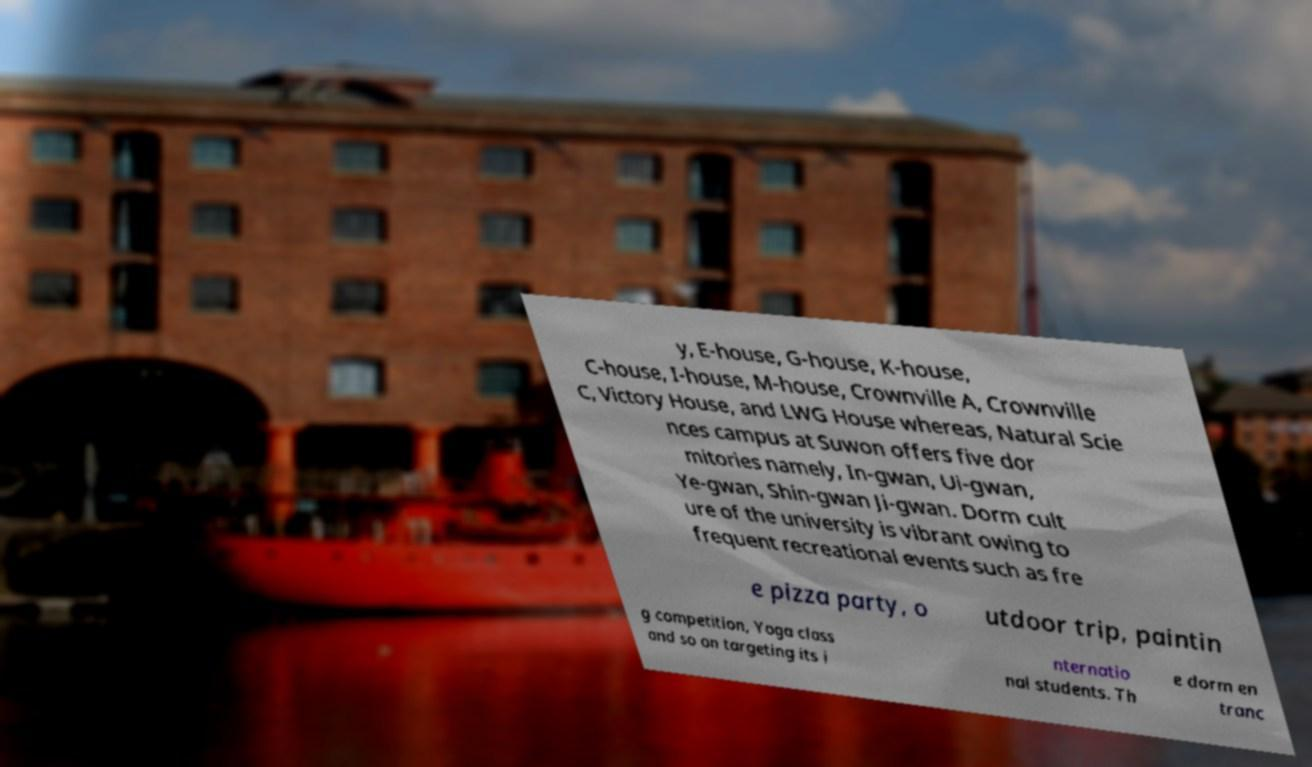I need the written content from this picture converted into text. Can you do that? y, E-house, G-house, K-house, C-house, I-house, M-house, Crownville A, Crownville C, Victory House, and LWG House whereas, Natural Scie nces campus at Suwon offers five dor mitories namely, In-gwan, Ui-gwan, Ye-gwan, Shin-gwan Ji-gwan. Dorm cult ure of the university is vibrant owing to frequent recreational events such as fre e pizza party, o utdoor trip, paintin g competition, Yoga class and so on targeting its i nternatio nal students. Th e dorm en tranc 